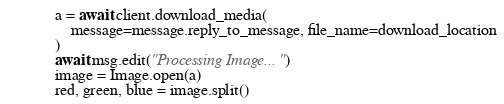Convert code to text. <code><loc_0><loc_0><loc_500><loc_500><_Python_>            a = await client.download_media(
                message=message.reply_to_message, file_name=download_location
            )
            await msg.edit("Processing Image...")
            image = Image.open(a)
            red, green, blue = image.split()</code> 